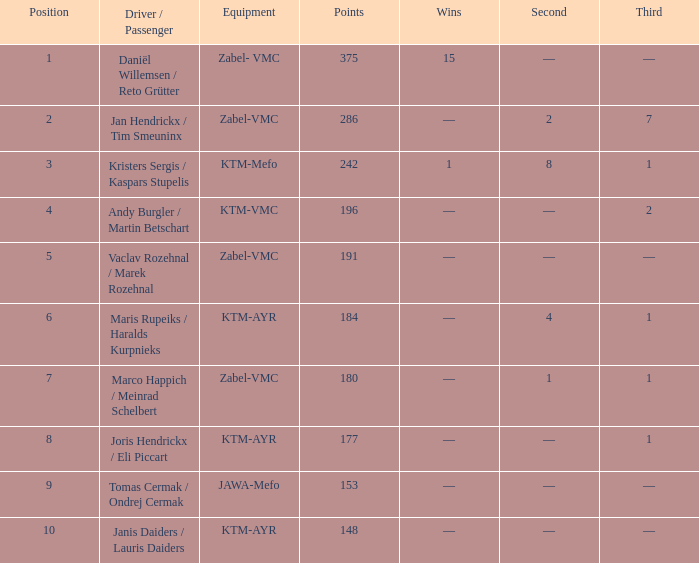Who was the chauffeur/traveler when the place was smaller than 8, the third was 1, and there was 1 triumph? Kristers Sergis / Kaspars Stupelis. 